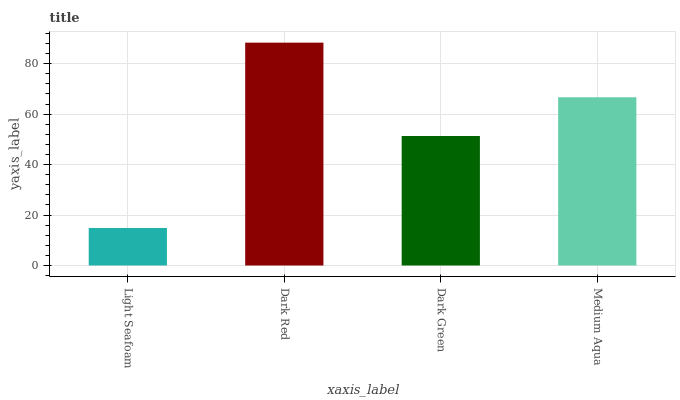Is Dark Green the minimum?
Answer yes or no. No. Is Dark Green the maximum?
Answer yes or no. No. Is Dark Red greater than Dark Green?
Answer yes or no. Yes. Is Dark Green less than Dark Red?
Answer yes or no. Yes. Is Dark Green greater than Dark Red?
Answer yes or no. No. Is Dark Red less than Dark Green?
Answer yes or no. No. Is Medium Aqua the high median?
Answer yes or no. Yes. Is Dark Green the low median?
Answer yes or no. Yes. Is Dark Red the high median?
Answer yes or no. No. Is Medium Aqua the low median?
Answer yes or no. No. 